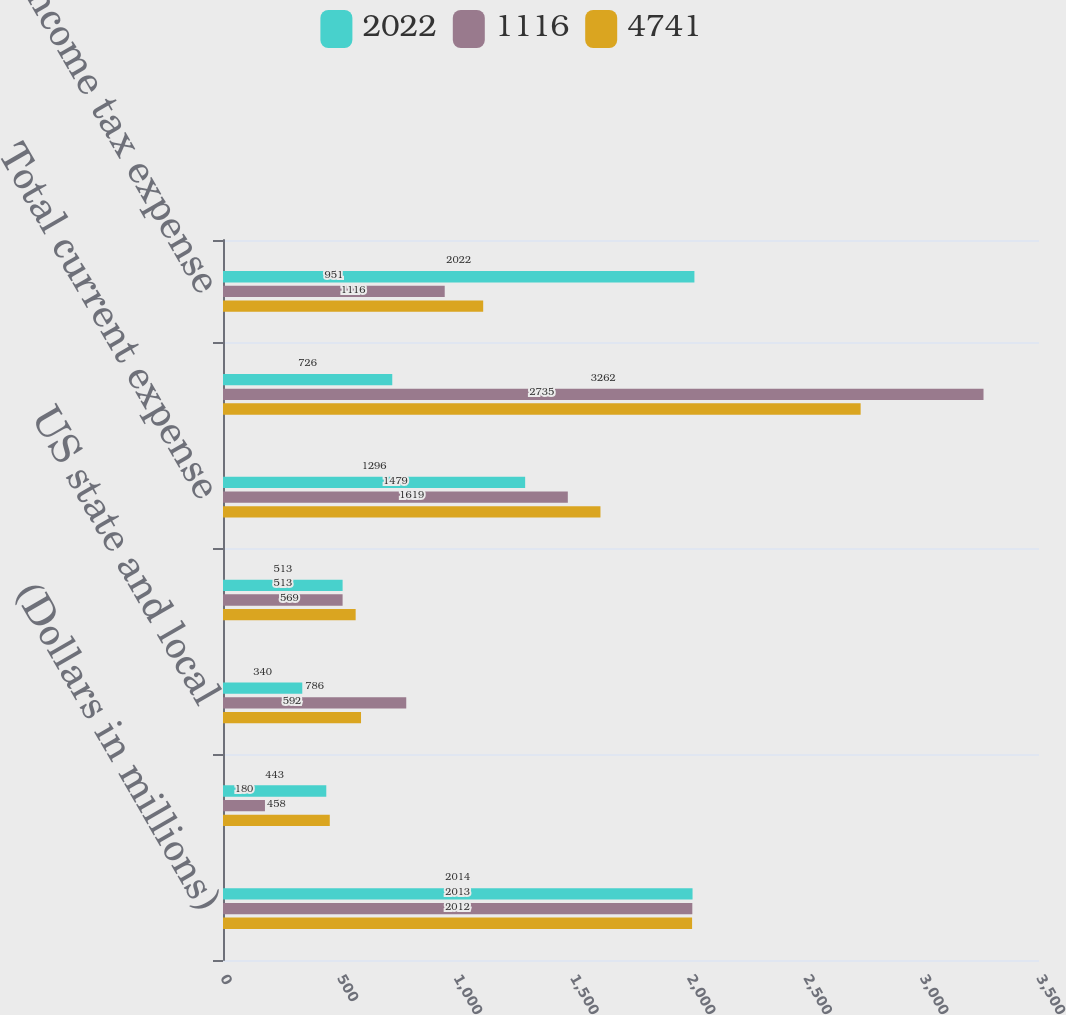<chart> <loc_0><loc_0><loc_500><loc_500><stacked_bar_chart><ecel><fcel>(Dollars in millions)<fcel>US federal<fcel>US state and local<fcel>Non-US<fcel>Total current expense<fcel>Total deferred expense<fcel>Total income tax expense<nl><fcel>2022<fcel>2014<fcel>443<fcel>340<fcel>513<fcel>1296<fcel>726<fcel>2022<nl><fcel>1116<fcel>2013<fcel>180<fcel>786<fcel>513<fcel>1479<fcel>3262<fcel>951<nl><fcel>4741<fcel>2012<fcel>458<fcel>592<fcel>569<fcel>1619<fcel>2735<fcel>1116<nl></chart> 